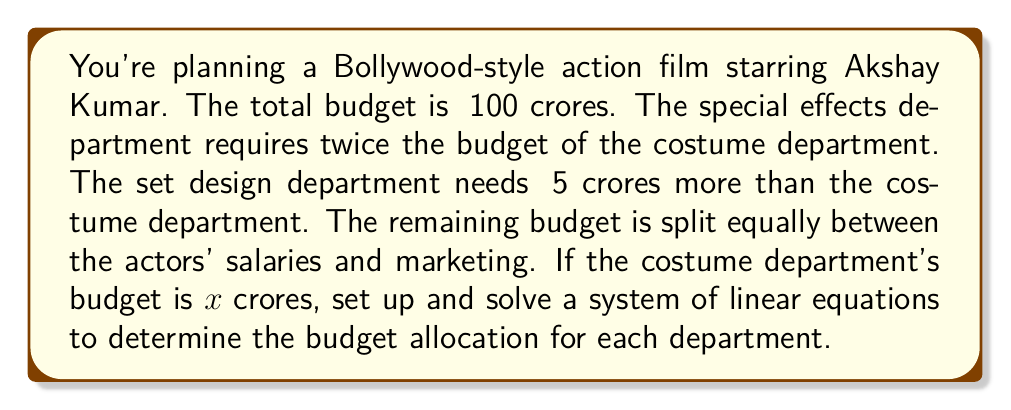Can you solve this math problem? Let's define our variables:
x = Costume department budget (in crores)
2x = Special effects department budget (in crores)
x + 5 = Set design department budget (in crores)
y = Actors' salaries and marketing budget each (in crores)

Step 1: Set up the equation based on the total budget
$$x + 2x + (x + 5) + 2y = 100$$

Step 2: Simplify the left side of the equation
$$4x + 5 + 2y = 100$$

Step 3: Isolate y
$$2y = 95 - 4x$$
$$y = \frac{95 - 4x}{2}$$

Step 4: Substitute this expression for y into the original equation
$$x + 2x + (x + 5) + 2(\frac{95 - 4x}{2}) = 100$$

Step 5: Simplify
$$4x + 5 + 95 - 4x = 100$$
$$100 = 100$$

Step 6: Solve for x
Since the equation is true for all values of x, we can choose x. Let's use x = 15 (costume department budget).

Step 7: Calculate the other budgets
Special effects: 2x = 2(15) = 30
Set design: x + 5 = 15 + 5 = 20
Actors' salaries and marketing: y = (95 - 4(15))/2 = 17.5 each

Step 8: Verify the total
15 + 30 + 20 + 17.5 + 17.5 = 100
Answer: Costume: ₹15 crores, Special effects: ₹30 crores, Set design: ₹20 crores, Actors' salaries: ₹17.5 crores, Marketing: ₹17.5 crores 